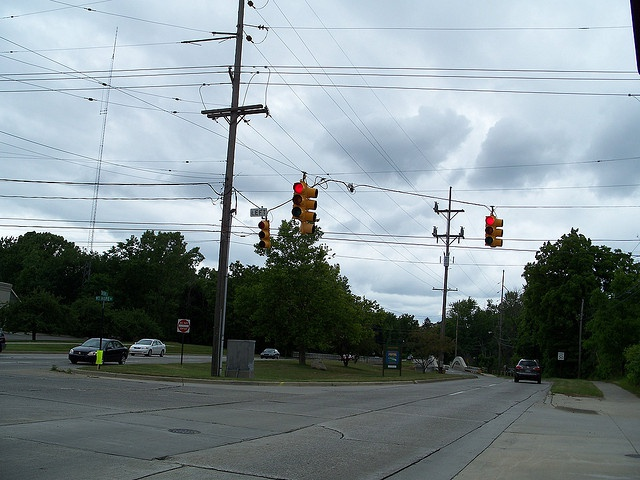Describe the objects in this image and their specific colors. I can see car in lightblue, black, gray, and blue tones, traffic light in lightblue, black, maroon, and white tones, car in lightblue, black, gray, and maroon tones, traffic light in lightblue, black, maroon, and white tones, and car in lightblue, gray, black, and darkgray tones in this image. 